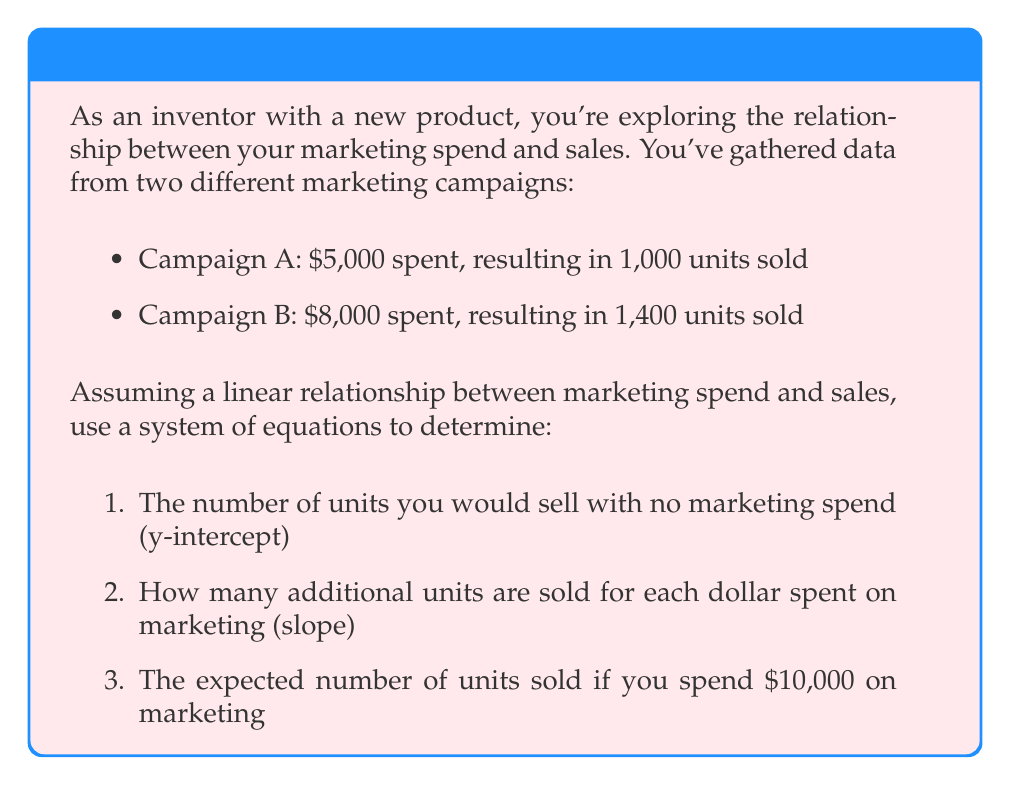Show me your answer to this math problem. Let's approach this step-by-step:

1) Let $x$ represent the marketing spend in dollars, and $y$ represent the number of units sold.

2) We can create a linear equation in the form $y = mx + b$, where $m$ is the slope (additional units sold per dollar spent) and $b$ is the y-intercept (units sold with no marketing).

3) Using the data from the two campaigns, we can create a system of equations:

   $$1000 = 5000m + b$$ (Campaign A)
   $$1400 = 8000m + b$$ (Campaign B)

4) To solve this system, let's subtract the first equation from the second:

   $$400 = 3000m$$

5) Solving for $m$:

   $$m = \frac{400}{3000} = \frac{2}{15} \approx 0.1333$$

6) Now we can substitute this value of $m$ into either of the original equations to solve for $b$. Let's use the first equation:

   $$1000 = 5000(\frac{2}{15}) + b$$
   $$1000 = 666.67 + b$$
   $$b = 333.33$$

7) So our equation is:

   $$y = \frac{2}{15}x + 333.33$$

8) To find the expected sales for $10,000 spent:

   $$y = \frac{2}{15}(10000) + 333.33 = 1666.67$$
Answer: 1) 333.33 units
2) 0.1333 units per dollar
3) 1666.67 units 